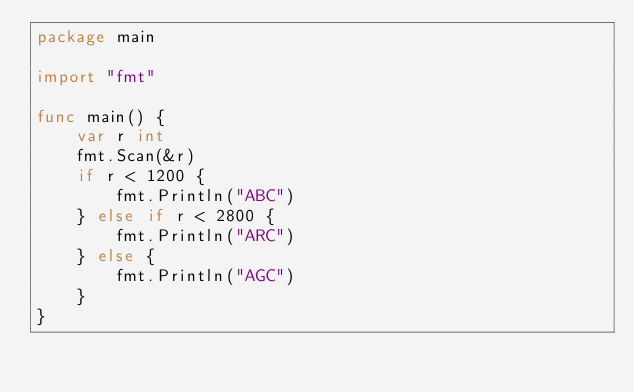Convert code to text. <code><loc_0><loc_0><loc_500><loc_500><_Go_>package main

import "fmt"

func main() {
	var r int
	fmt.Scan(&r)
	if r < 1200 {
		fmt.Println("ABC")
	} else if r < 2800 {
		fmt.Println("ARC")
	} else {
		fmt.Println("AGC")
	}
}</code> 